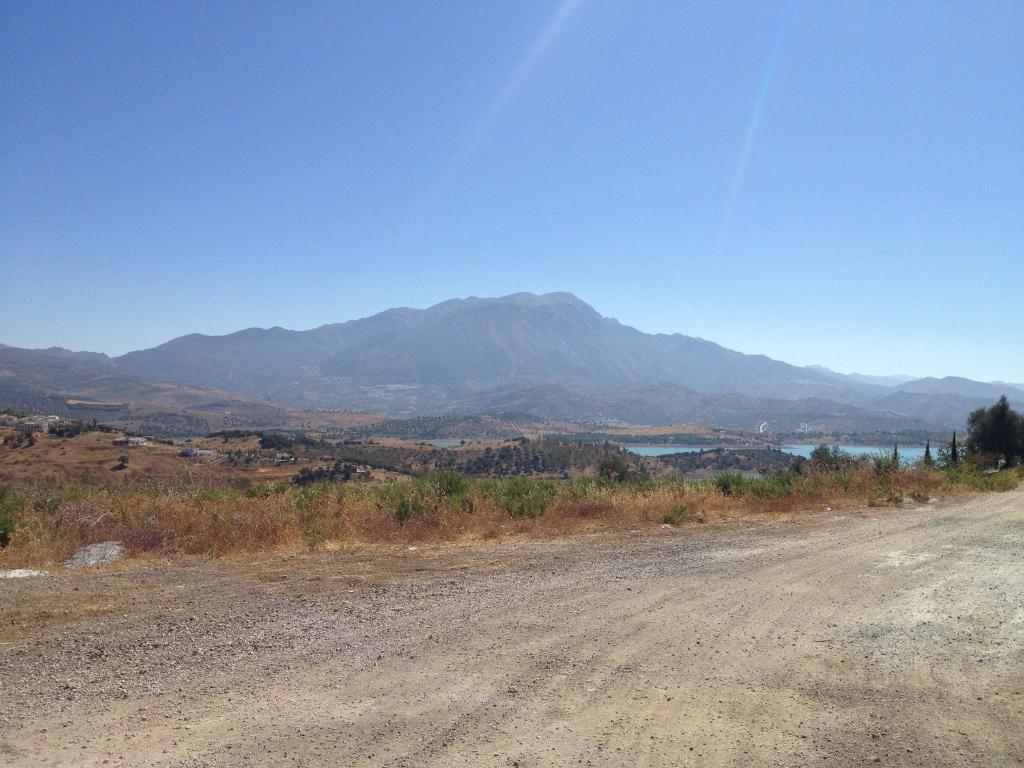What type of road is visible in the front of the image? There is a dirt road in the front of the image. What can be seen in the center of the image? There are plants and water in the center of the image. What type of natural feature is visible at the back of the image? There are mountains at the back of the image. What is visible at the top of the image? The sky is visible at the top of the image. How does the feeling of happiness appear in the image? There is no representation of feelings or emotions in the image; it depicts a landscape with a dirt road, plants, water, mountains, and sky. Is there a crib present in the image for someone to sleep in? There is no crib or any indication of sleeping in the image; it shows a natural landscape. 